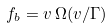Convert formula to latex. <formula><loc_0><loc_0><loc_500><loc_500>f _ { b } = v \, \Omega ( v / \Gamma )</formula> 